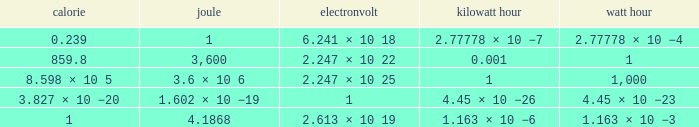How many calories is 1 watt hour? 859.8. 